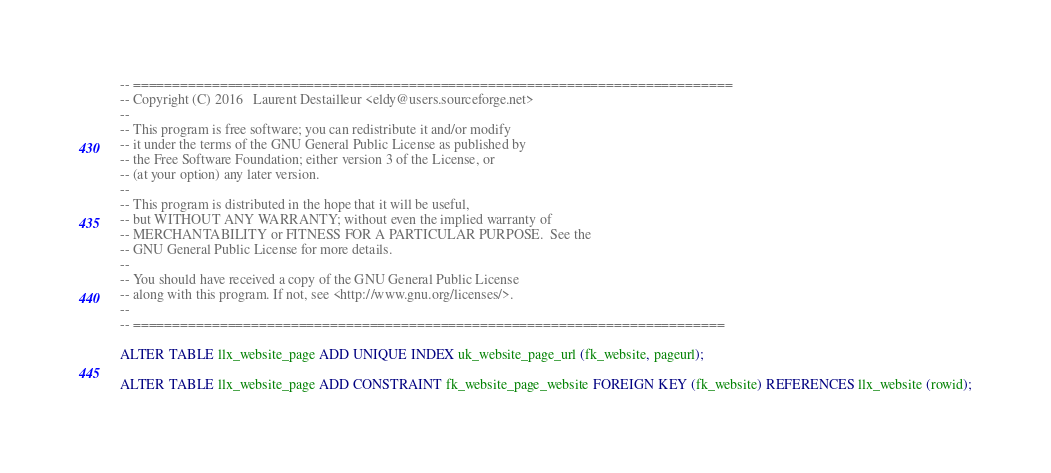Convert code to text. <code><loc_0><loc_0><loc_500><loc_500><_SQL_>-- ============================================================================
-- Copyright (C) 2016	Laurent Destailleur	<eldy@users.sourceforge.net>
--
-- This program is free software; you can redistribute it and/or modify
-- it under the terms of the GNU General Public License as published by
-- the Free Software Foundation; either version 3 of the License, or
-- (at your option) any later version.
--
-- This program is distributed in the hope that it will be useful,
-- but WITHOUT ANY WARRANTY; without even the implied warranty of
-- MERCHANTABILITY or FITNESS FOR A PARTICULAR PURPOSE.  See the
-- GNU General Public License for more details.
--
-- You should have received a copy of the GNU General Public License
-- along with this program. If not, see <http://www.gnu.org/licenses/>.
--
-- ===========================================================================

ALTER TABLE llx_website_page ADD UNIQUE INDEX uk_website_page_url (fk_website, pageurl);

ALTER TABLE llx_website_page ADD CONSTRAINT fk_website_page_website FOREIGN KEY (fk_website) REFERENCES llx_website (rowid);

</code> 